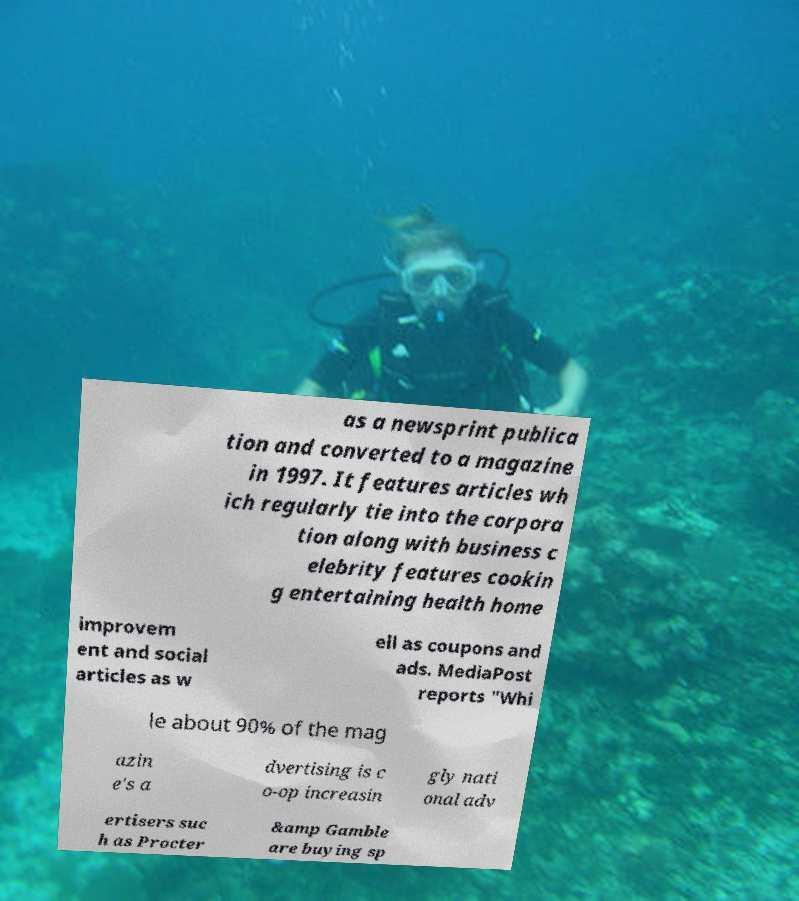Can you accurately transcribe the text from the provided image for me? as a newsprint publica tion and converted to a magazine in 1997. It features articles wh ich regularly tie into the corpora tion along with business c elebrity features cookin g entertaining health home improvem ent and social articles as w ell as coupons and ads. MediaPost reports "Whi le about 90% of the mag azin e's a dvertising is c o-op increasin gly nati onal adv ertisers suc h as Procter &amp Gamble are buying sp 